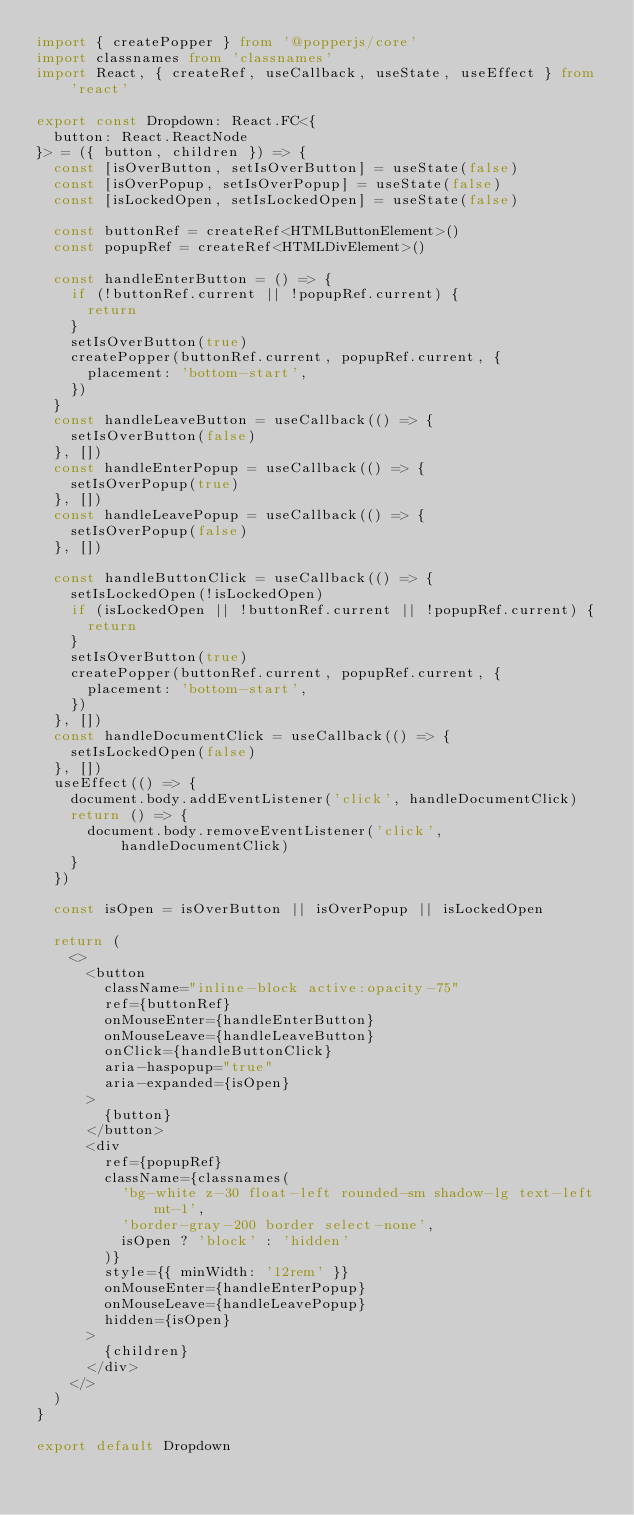Convert code to text. <code><loc_0><loc_0><loc_500><loc_500><_TypeScript_>import { createPopper } from '@popperjs/core'
import classnames from 'classnames'
import React, { createRef, useCallback, useState, useEffect } from 'react'

export const Dropdown: React.FC<{
  button: React.ReactNode
}> = ({ button, children }) => {
  const [isOverButton, setIsOverButton] = useState(false)
  const [isOverPopup, setIsOverPopup] = useState(false)
  const [isLockedOpen, setIsLockedOpen] = useState(false)

  const buttonRef = createRef<HTMLButtonElement>()
  const popupRef = createRef<HTMLDivElement>()

  const handleEnterButton = () => {
    if (!buttonRef.current || !popupRef.current) {
      return
    }
    setIsOverButton(true)
    createPopper(buttonRef.current, popupRef.current, {
      placement: 'bottom-start',
    })
  }
  const handleLeaveButton = useCallback(() => {
    setIsOverButton(false)
  }, [])
  const handleEnterPopup = useCallback(() => {
    setIsOverPopup(true)
  }, [])
  const handleLeavePopup = useCallback(() => {
    setIsOverPopup(false)
  }, [])

  const handleButtonClick = useCallback(() => {
    setIsLockedOpen(!isLockedOpen)
    if (isLockedOpen || !buttonRef.current || !popupRef.current) {
      return
    }
    setIsOverButton(true)
    createPopper(buttonRef.current, popupRef.current, {
      placement: 'bottom-start',
    })
  }, [])
  const handleDocumentClick = useCallback(() => {
    setIsLockedOpen(false)
  }, [])
  useEffect(() => {
    document.body.addEventListener('click', handleDocumentClick)
    return () => {
      document.body.removeEventListener('click', handleDocumentClick)
    }
  })

  const isOpen = isOverButton || isOverPopup || isLockedOpen

  return (
    <>
      <button
        className="inline-block active:opacity-75"
        ref={buttonRef}
        onMouseEnter={handleEnterButton}
        onMouseLeave={handleLeaveButton}
        onClick={handleButtonClick}
        aria-haspopup="true"
        aria-expanded={isOpen}
      >
        {button}
      </button>
      <div
        ref={popupRef}
        className={classnames(
          'bg-white z-30 float-left rounded-sm shadow-lg text-left mt-1',
          'border-gray-200 border select-none',
          isOpen ? 'block' : 'hidden'
        )}
        style={{ minWidth: '12rem' }}
        onMouseEnter={handleEnterPopup}
        onMouseLeave={handleLeavePopup}
        hidden={isOpen}
      >
        {children}
      </div>
    </>
  )
}

export default Dropdown
</code> 